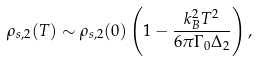Convert formula to latex. <formula><loc_0><loc_0><loc_500><loc_500>\rho _ { s , 2 } ( T ) \sim \rho _ { s , 2 } ( 0 ) \left ( 1 - \frac { k _ { B } ^ { 2 } T ^ { 2 } } { 6 \pi \Gamma _ { 0 } \Delta _ { 2 } } \right ) ,</formula> 